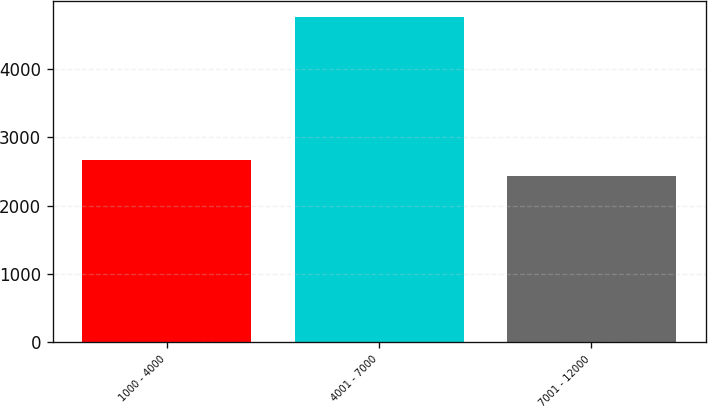Convert chart. <chart><loc_0><loc_0><loc_500><loc_500><bar_chart><fcel>1000 - 4000<fcel>4001 - 7000<fcel>7001 - 12000<nl><fcel>2668.2<fcel>4749<fcel>2437<nl></chart> 